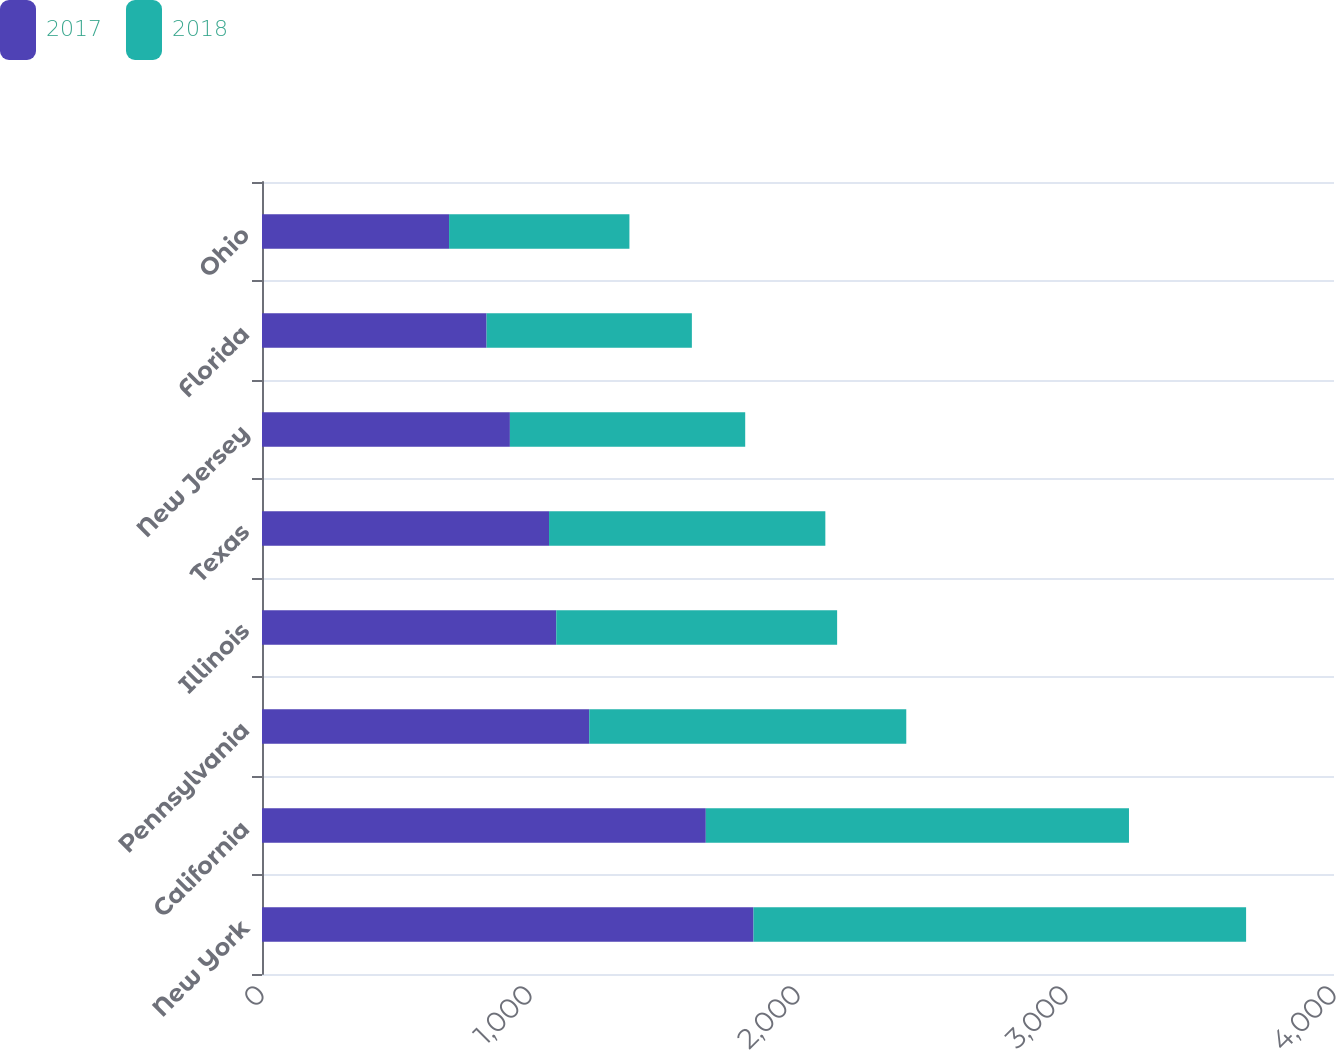Convert chart to OTSL. <chart><loc_0><loc_0><loc_500><loc_500><stacked_bar_chart><ecel><fcel>New York<fcel>California<fcel>Pennsylvania<fcel>Illinois<fcel>Texas<fcel>New Jersey<fcel>Florida<fcel>Ohio<nl><fcel>2017<fcel>1834<fcel>1656<fcel>1221<fcel>1098<fcel>1071<fcel>925<fcel>838<fcel>698<nl><fcel>2018<fcel>1838<fcel>1579<fcel>1183<fcel>1048<fcel>1031<fcel>878<fcel>766<fcel>673<nl></chart> 